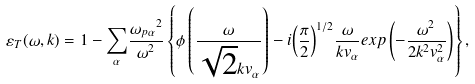Convert formula to latex. <formula><loc_0><loc_0><loc_500><loc_500>\varepsilon _ { T } ( { \omega } , { k } ) = 1 - { \sum _ { \alpha } } \frac { { { \omega } _ { p \alpha } } ^ { 2 } } { { \omega } ^ { 2 } } \left \{ \phi \left ( \frac { \omega } { \sqrt { 2 } k { v _ { \alpha } } } \right ) - i { \left ( \frac { \pi } { 2 } \right ) } ^ { 1 / 2 } \frac { \omega } { k v _ { \alpha } } { e x p \left ( - \frac { { \omega } ^ { 2 } } { 2 k ^ { 2 } { v _ { \alpha } ^ { 2 } } } \right ) } \right \} ,</formula> 